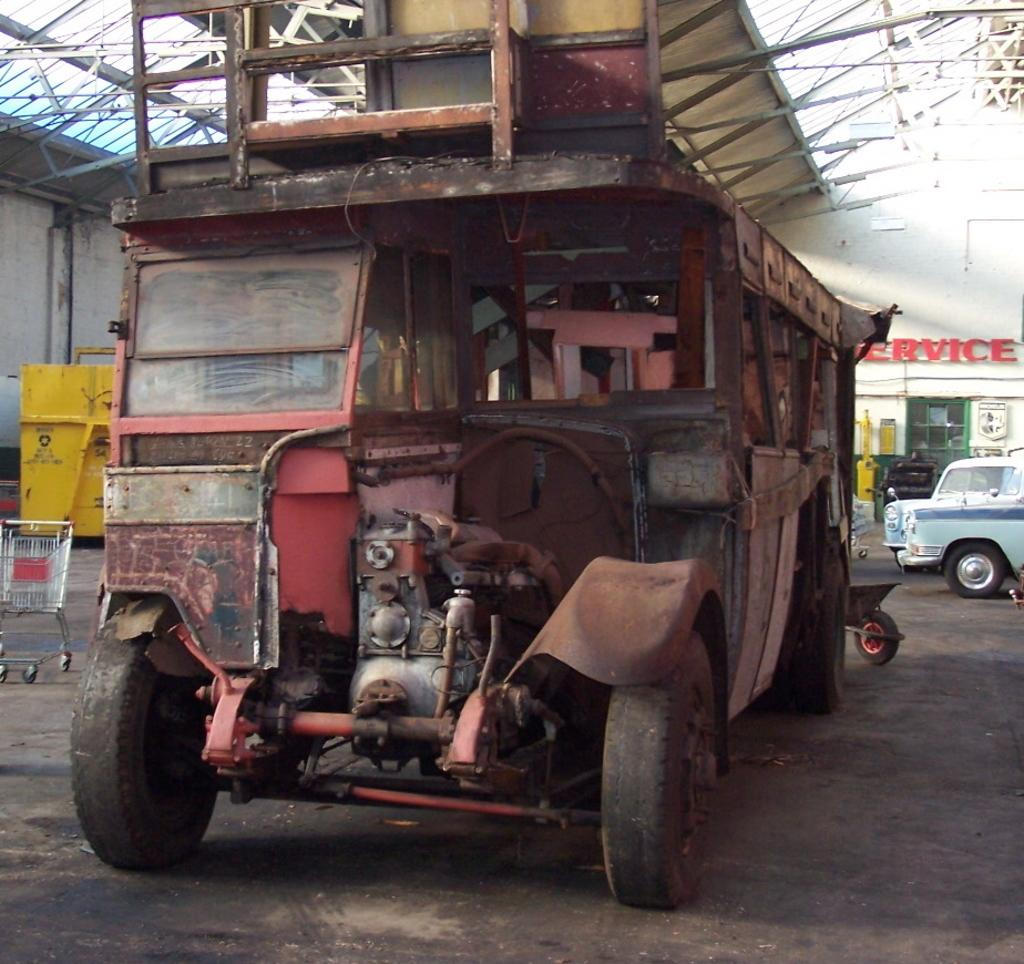What type of vehicles are present in the image? There are cars and a truck in the image. What can be seen on the wall in the image? There is text on a wall in the image. Where is the shopping cart located in the image? The shopping cart is on the left side of the image. How many babies are sitting on the stove in the image? There is no stove or babies present in the image. What type of bulb is used to illuminate the text on the wall in the image? There is no information about the type of bulb used to illuminate the text on the wall in the image. 